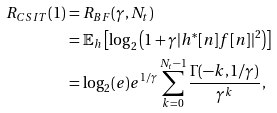<formula> <loc_0><loc_0><loc_500><loc_500>R _ { C S I T } ( 1 ) & = R _ { B F } ( \gamma , N _ { t } ) \\ & = \mathbb { E } _ { h } \left [ \log _ { 2 } \left ( 1 + \gamma | h ^ { * } [ n ] f [ n ] | ^ { 2 } \right ) \right ] \\ & = \log _ { 2 } ( e ) e ^ { 1 / \gamma } \sum _ { k = 0 } ^ { N _ { t } - 1 } \frac { \Gamma ( - k , 1 / \gamma ) } { \gamma ^ { k } } ,</formula> 